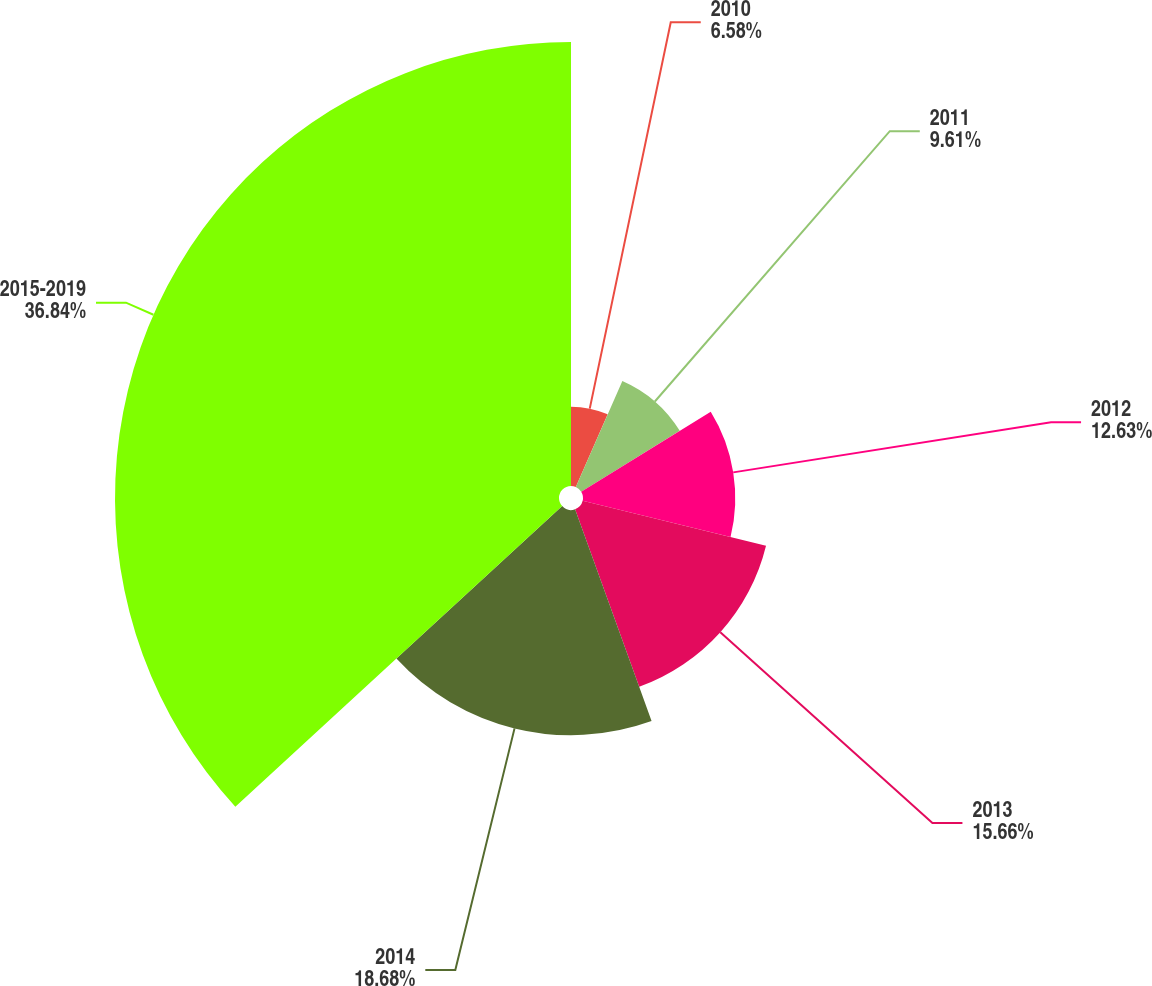<chart> <loc_0><loc_0><loc_500><loc_500><pie_chart><fcel>2010<fcel>2011<fcel>2012<fcel>2013<fcel>2014<fcel>2015-2019<nl><fcel>6.58%<fcel>9.61%<fcel>12.63%<fcel>15.66%<fcel>18.68%<fcel>36.83%<nl></chart> 